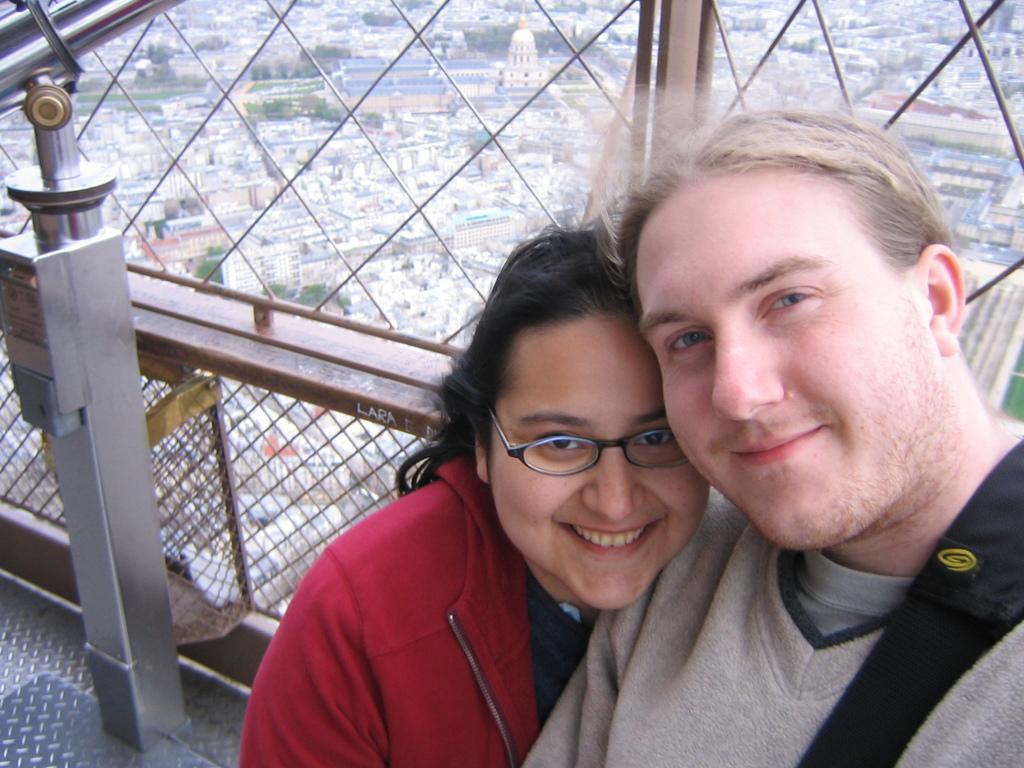Please provide a concise description of this image. In the bottom right corner of the image two persons are standing and smiling. Behind them there is fencing. Through the fencing we can see some trees and buildings. 